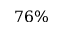Convert formula to latex. <formula><loc_0><loc_0><loc_500><loc_500>7 6 \%</formula> 